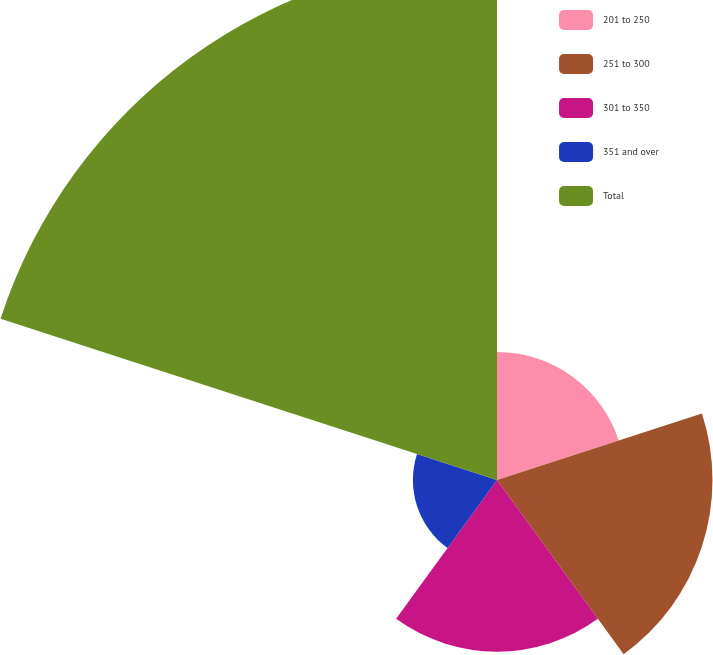Convert chart to OTSL. <chart><loc_0><loc_0><loc_500><loc_500><pie_chart><fcel>201 to 250<fcel>251 to 300<fcel>301 to 350<fcel>351 and over<fcel>Total<nl><fcel>11.41%<fcel>19.22%<fcel>15.31%<fcel>7.5%<fcel>46.56%<nl></chart> 